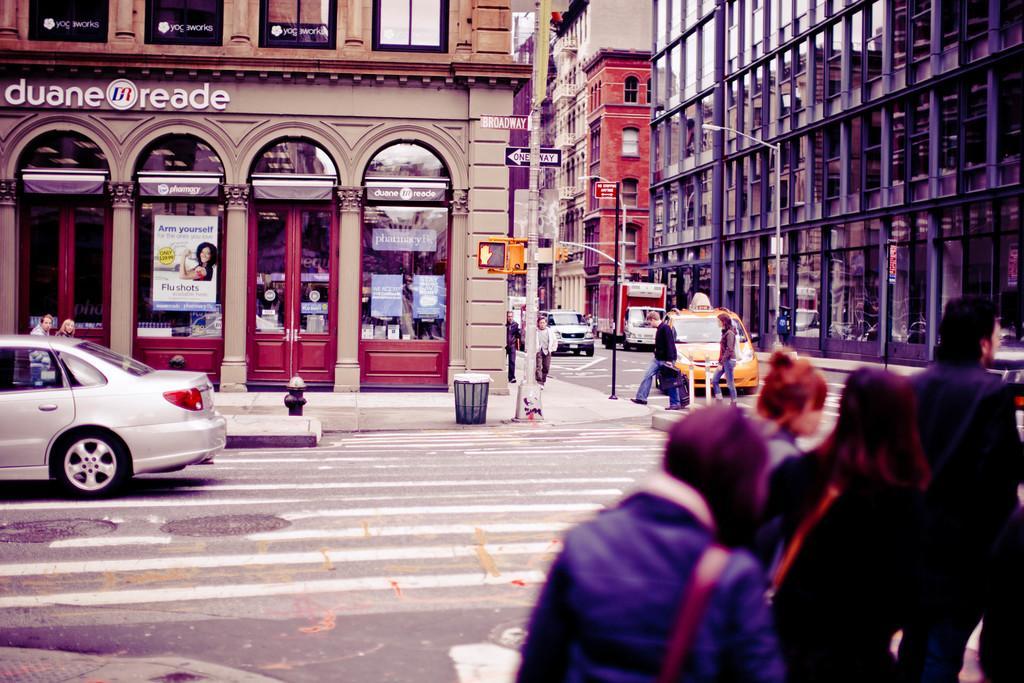Please provide a concise description of this image. In this image, there are few people walking and few people standing. I can see the buildings with the glass doors. These are the vehicles on the road. There is a dustbin and a pole, which are in front of a building. 